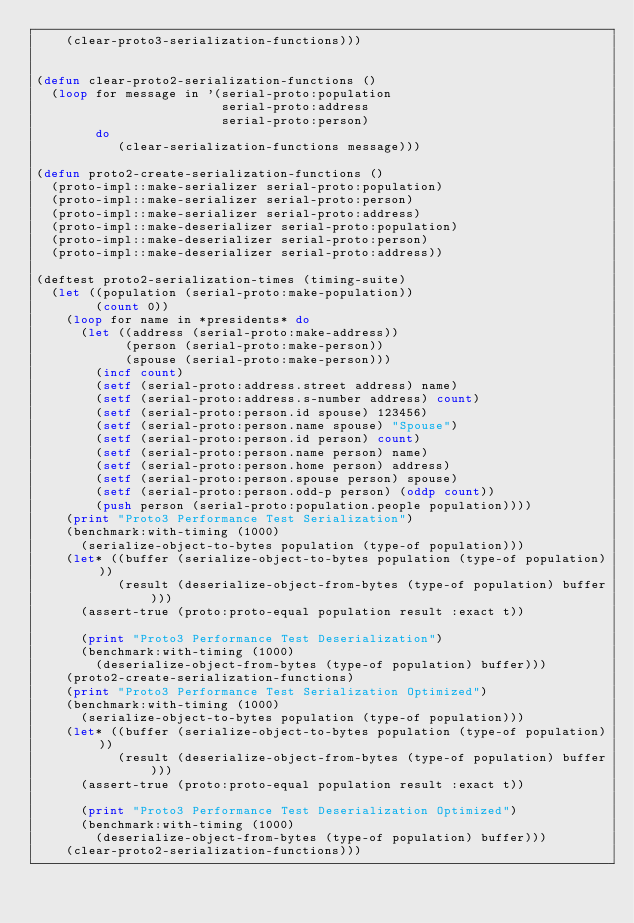<code> <loc_0><loc_0><loc_500><loc_500><_Lisp_>    (clear-proto3-serialization-functions)))


(defun clear-proto2-serialization-functions ()
  (loop for message in '(serial-proto:population
                         serial-proto:address
                         serial-proto:person)
        do
           (clear-serialization-functions message)))

(defun proto2-create-serialization-functions ()
  (proto-impl::make-serializer serial-proto:population)
  (proto-impl::make-serializer serial-proto:person)
  (proto-impl::make-serializer serial-proto:address)
  (proto-impl::make-deserializer serial-proto:population)
  (proto-impl::make-deserializer serial-proto:person)
  (proto-impl::make-deserializer serial-proto:address))

(deftest proto2-serialization-times (timing-suite)
  (let ((population (serial-proto:make-population))
        (count 0))
    (loop for name in *presidents* do
      (let ((address (serial-proto:make-address))
            (person (serial-proto:make-person))
            (spouse (serial-proto:make-person)))
        (incf count)
        (setf (serial-proto:address.street address) name)
        (setf (serial-proto:address.s-number address) count)
        (setf (serial-proto:person.id spouse) 123456)
        (setf (serial-proto:person.name spouse) "Spouse")
        (setf (serial-proto:person.id person) count)
        (setf (serial-proto:person.name person) name)
        (setf (serial-proto:person.home person) address)
        (setf (serial-proto:person.spouse person) spouse)
        (setf (serial-proto:person.odd-p person) (oddp count))
        (push person (serial-proto:population.people population))))
    (print "Proto3 Performance Test Serialization")
    (benchmark:with-timing (1000)
      (serialize-object-to-bytes population (type-of population)))
    (let* ((buffer (serialize-object-to-bytes population (type-of population)))
           (result (deserialize-object-from-bytes (type-of population) buffer)))
      (assert-true (proto:proto-equal population result :exact t))

      (print "Proto3 Performance Test Deserialization")
      (benchmark:with-timing (1000)
        (deserialize-object-from-bytes (type-of population) buffer)))
    (proto2-create-serialization-functions)
    (print "Proto3 Performance Test Serialization Optimized")
    (benchmark:with-timing (1000)
      (serialize-object-to-bytes population (type-of population)))
    (let* ((buffer (serialize-object-to-bytes population (type-of population)))
           (result (deserialize-object-from-bytes (type-of population) buffer)))
      (assert-true (proto:proto-equal population result :exact t))

      (print "Proto3 Performance Test Deserialization Optimized")
      (benchmark:with-timing (1000)
        (deserialize-object-from-bytes (type-of population) buffer)))
    (clear-proto2-serialization-functions)))
</code> 